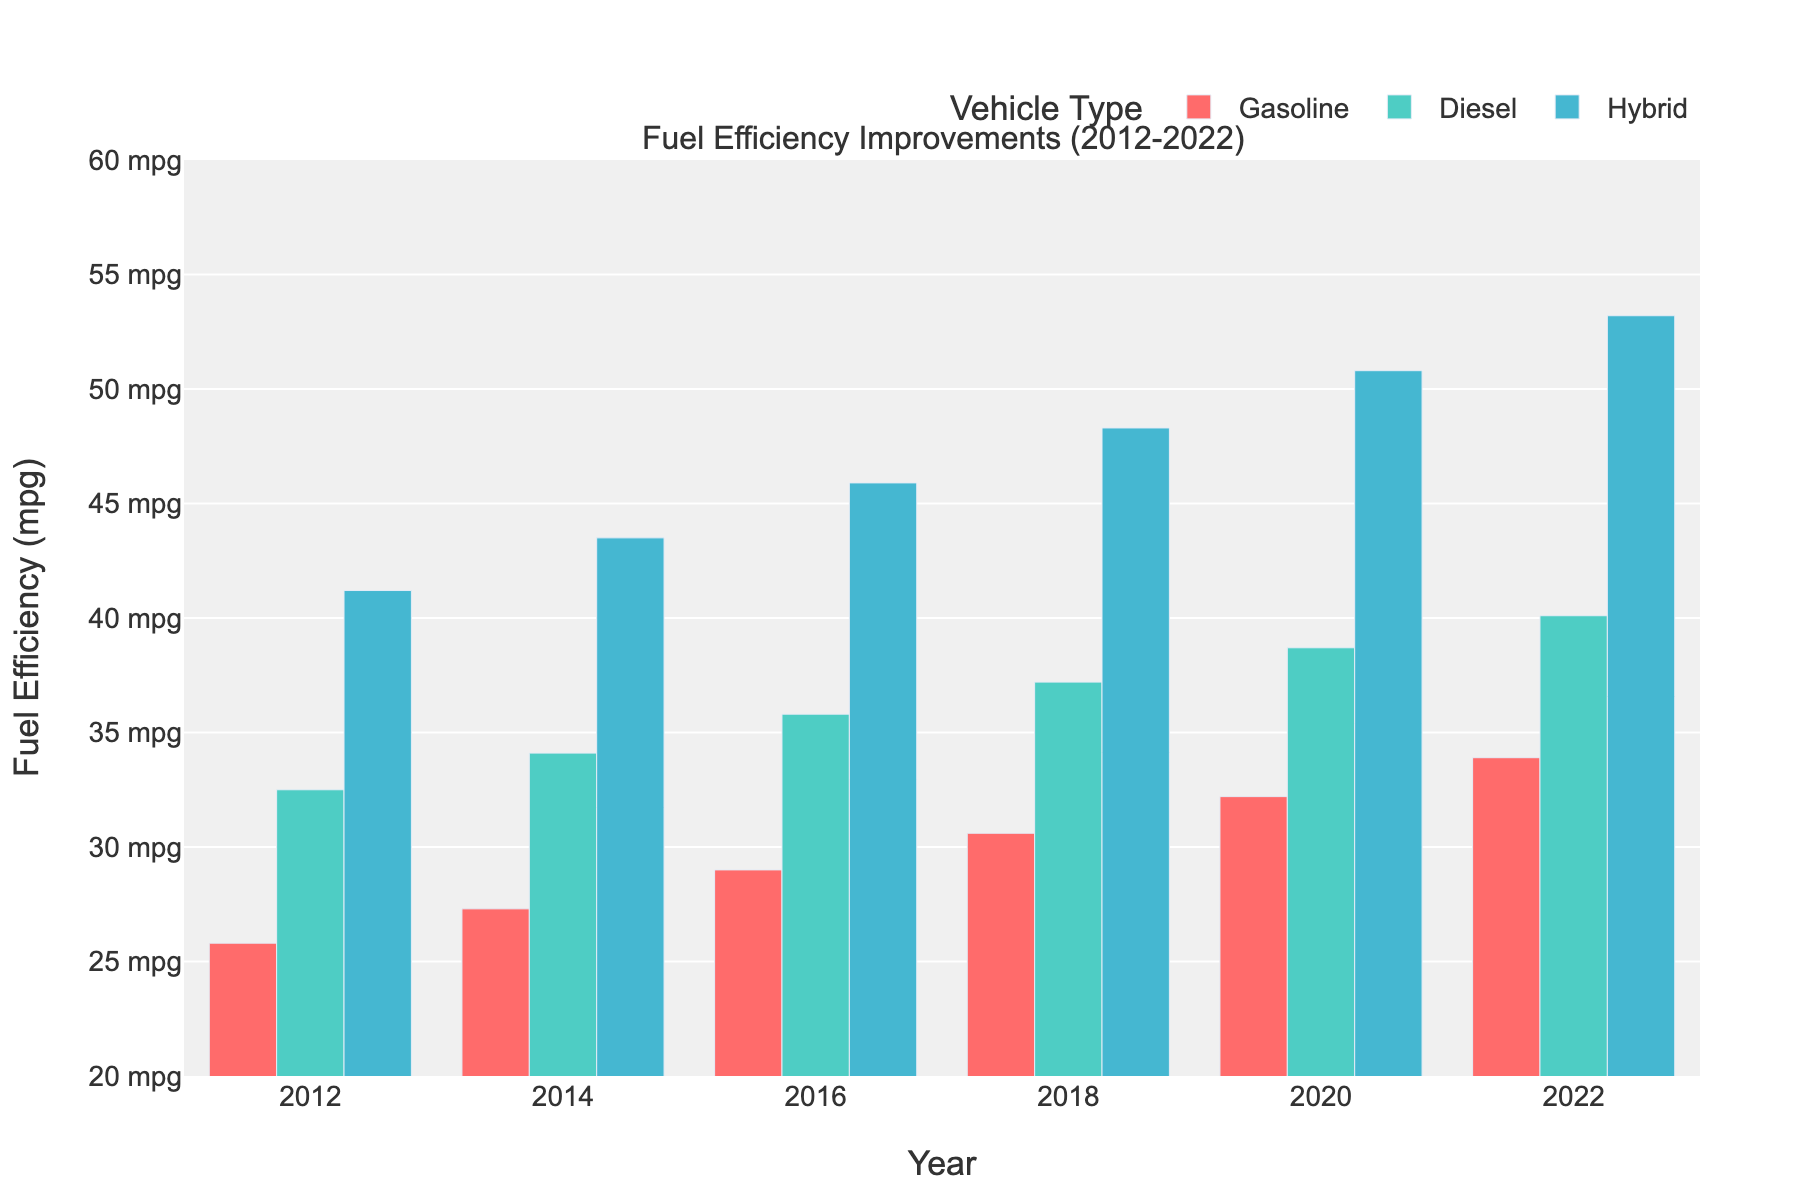Which vehicle type showed the greatest improvement in fuel efficiency from 2012 to 2022? Calculate the difference in fuel efficiency for each vehicle type between 2012 and 2022. Gasoline improved from 25.8 to 33.9 (an increase of 8.1), Diesel from 32.5 to 40.1 (an increase of 7.6), and Hybrid from 41.2 to 53.2 (an increase of 12). Hybrid has the greatest improvement.
Answer: Hybrid In what year did Diesel vehicles surpass a fuel efficiency of 35 mpg? Analyze the data points for the Diesel category and identify the first year where the value exceeds 35 mpg. The Diesel fuel efficiency exceeds 35 mpg starting in 2016.
Answer: 2016 Which vehicle type had the smallest increase in fuel efficiency from 2014 to 2018? Calculate the increase for each vehicle type: Gasoline from 27.3 to 30.6 (an increase of 3.3), Diesel from 34.1 to 37.2 (an increase of 3.1), Hybrid from 43.5 to 48.3 (an increase of 4.8). Diesel had the smallest increase.
Answer: Diesel What's the total fuel efficiency for each vehicle type in 2020? Read the fuel efficiency values for 2020 from the chart: Gasoline is 32.2 mpg, Diesel is 38.7 mpg, Hybrid is 50.8 mpg. Add them together to get the total. Total = 32.2 + 38.7 + 50.8 = 121.7 mpg.
Answer: 121.7 mpg Did any vehicle type experience a year-over-year decrease in fuel efficiency? Examine the bar heights for each vehicle type year-over-year to identify any decreases. All vehicle types show a consistent increase over the years, so no decreases are found.
Answer: No How many mpg did Gasoline vehicles improve by from 2012 to 2014? Calculate the difference in Gasoline fuel efficiency between 2012 (25.8 mpg) and 2014 (27.3 mpg). The improvement is 27.3 - 25.8 = 1.5 mpg.
Answer: 1.5 mpg Which year saw the largest yearly increase in fuel efficiency for Hybrid vehicles? Determine the yearly differences in Hybrid fuel efficiency: 2014: 43.5-41.2=2.3, 2016: 45.9-43.5=2.4, 2018: 48.3-45.9=2.4, 2020: 50.8-48.3=2.5, 2022: 53.2-50.8=2.4. The largest increase is from 2020 to 2022 (2.5 mpg).
Answer: 2020 What is the average fuel efficiency of Diesel vehicles over the decade? Calculate the average fuel efficiency by summing the yearly values: (32.5 + 34.1 + 35.8 + 37.2 + 38.7 + 40.1) / 6 = 36.4 mpg.
Answer: 36.4 mpg In 2018, did Gasoline or Diesel vehicles have higher fuel efficiency? Compare the 2018 values: Gasoline is 30.6 mpg, Diesel is 37.2 mpg. Diesel is higher.
Answer: Diesel 